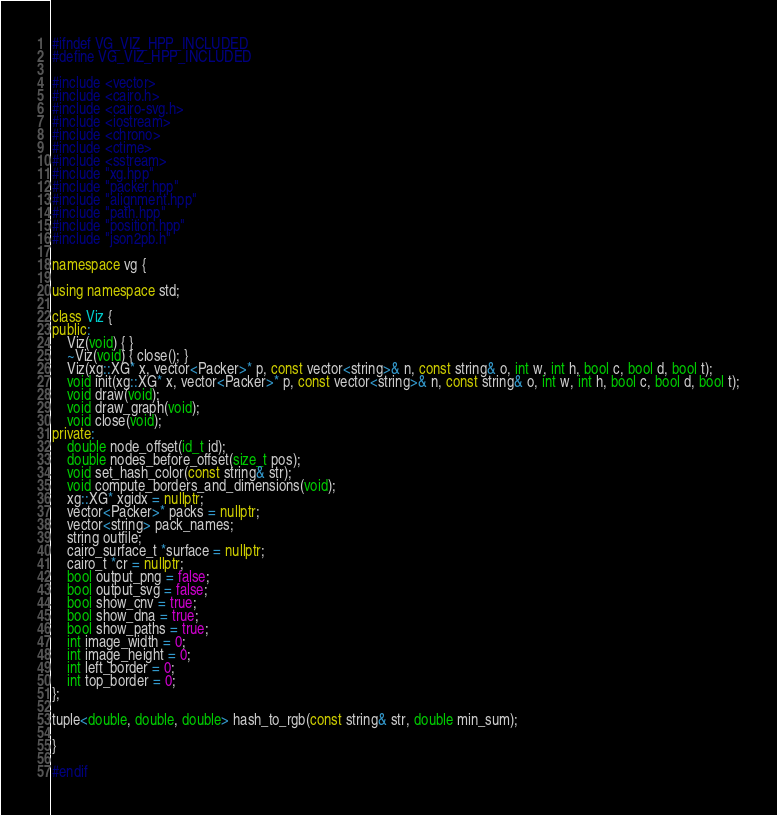Convert code to text. <code><loc_0><loc_0><loc_500><loc_500><_C++_>#ifndef VG_VIZ_HPP_INCLUDED
#define VG_VIZ_HPP_INCLUDED

#include <vector>
#include <cairo.h>
#include <cairo-svg.h>
#include <iostream>
#include <chrono>
#include <ctime>
#include <sstream>
#include "xg.hpp"
#include "packer.hpp"
#include "alignment.hpp"
#include "path.hpp"
#include "position.hpp"
#include "json2pb.h"

namespace vg {

using namespace std;

class Viz {
public:
    Viz(void) { }
    ~Viz(void) { close(); }
    Viz(xg::XG* x, vector<Packer>* p, const vector<string>& n, const string& o, int w, int h, bool c, bool d, bool t);
    void init(xg::XG* x, vector<Packer>* p, const vector<string>& n, const string& o, int w, int h, bool c, bool d, bool t);
    void draw(void);
    void draw_graph(void);
    void close(void);
private:
    double node_offset(id_t id);
    double nodes_before_offset(size_t pos);
    void set_hash_color(const string& str);
    void compute_borders_and_dimensions(void);
    xg::XG* xgidx = nullptr;
    vector<Packer>* packs = nullptr;
    vector<string> pack_names;
    string outfile;
    cairo_surface_t *surface = nullptr;
	cairo_t *cr = nullptr;
    bool output_png = false;
    bool output_svg = false;
    bool show_cnv = true;
    bool show_dna = true;
    bool show_paths = true;
    int image_width = 0;
    int image_height = 0;
    int left_border = 0;
    int top_border = 0;
};

tuple<double, double, double> hash_to_rgb(const string& str, double min_sum);

}

#endif
</code> 